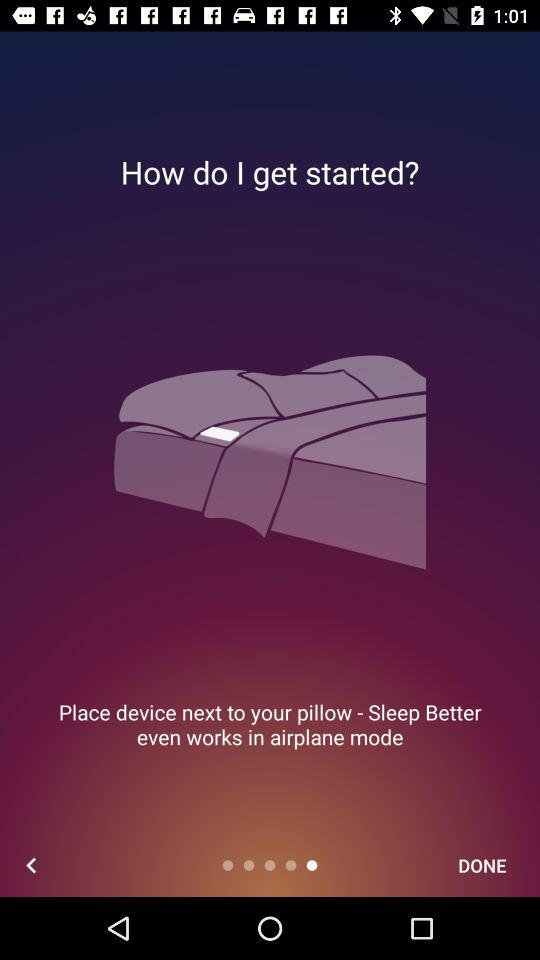Does the device work in airplane mode? The device works in airplane mode. 